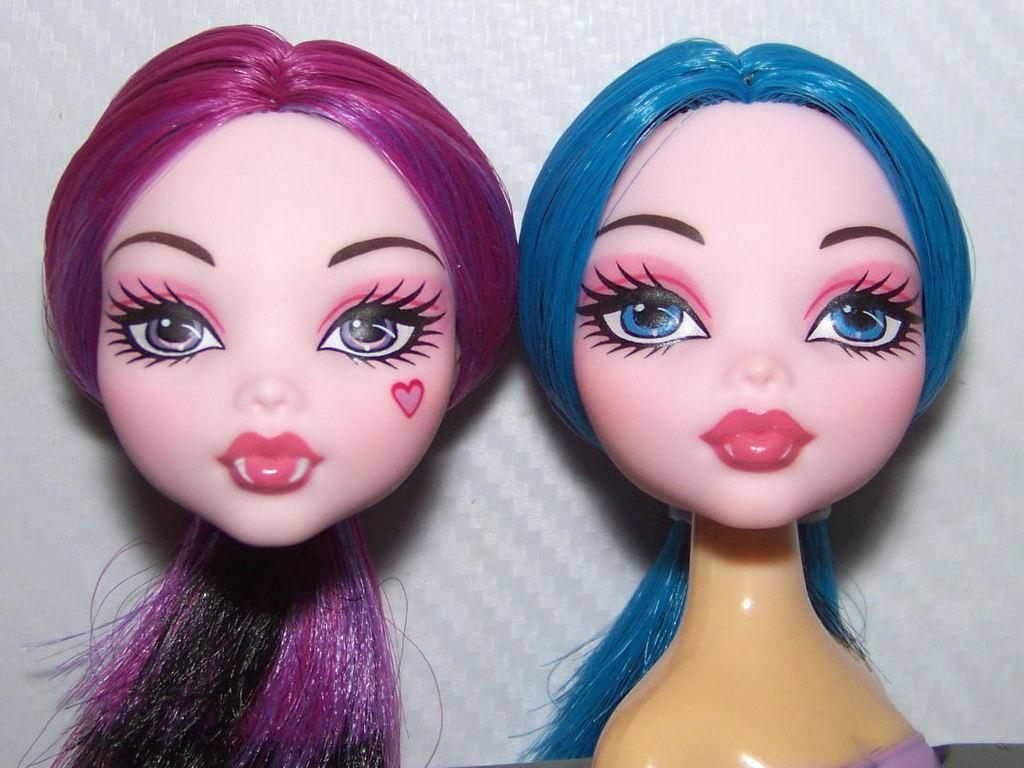How many toys can be seen in the image? There are two toys in the image. What can be observed about the background of the image? The background of the image is white in color. Is there a turkey sitting next to the toys in the image? No, there is no turkey present in the image. What type of support is being used by the toys in the image? The toys do not require any support in the image, as they are likely resting on a surface or held by someone. 